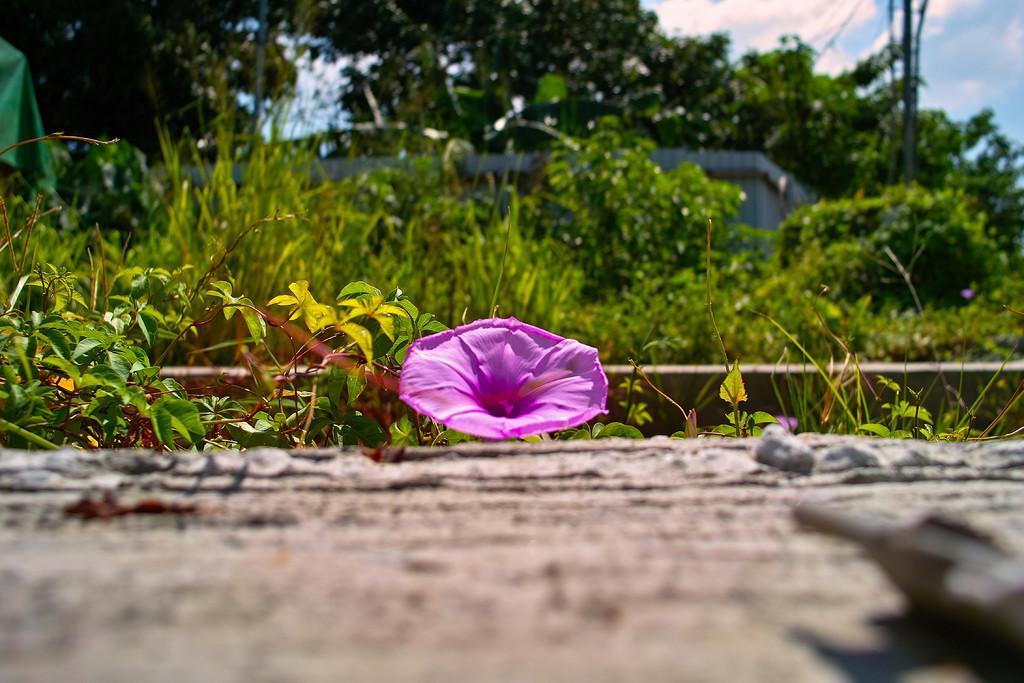Please provide a concise description of this image. Here in this picture in the middle we can see a flower present on the ground and we can also see plants and trees present and we can see clouds in the sky. 